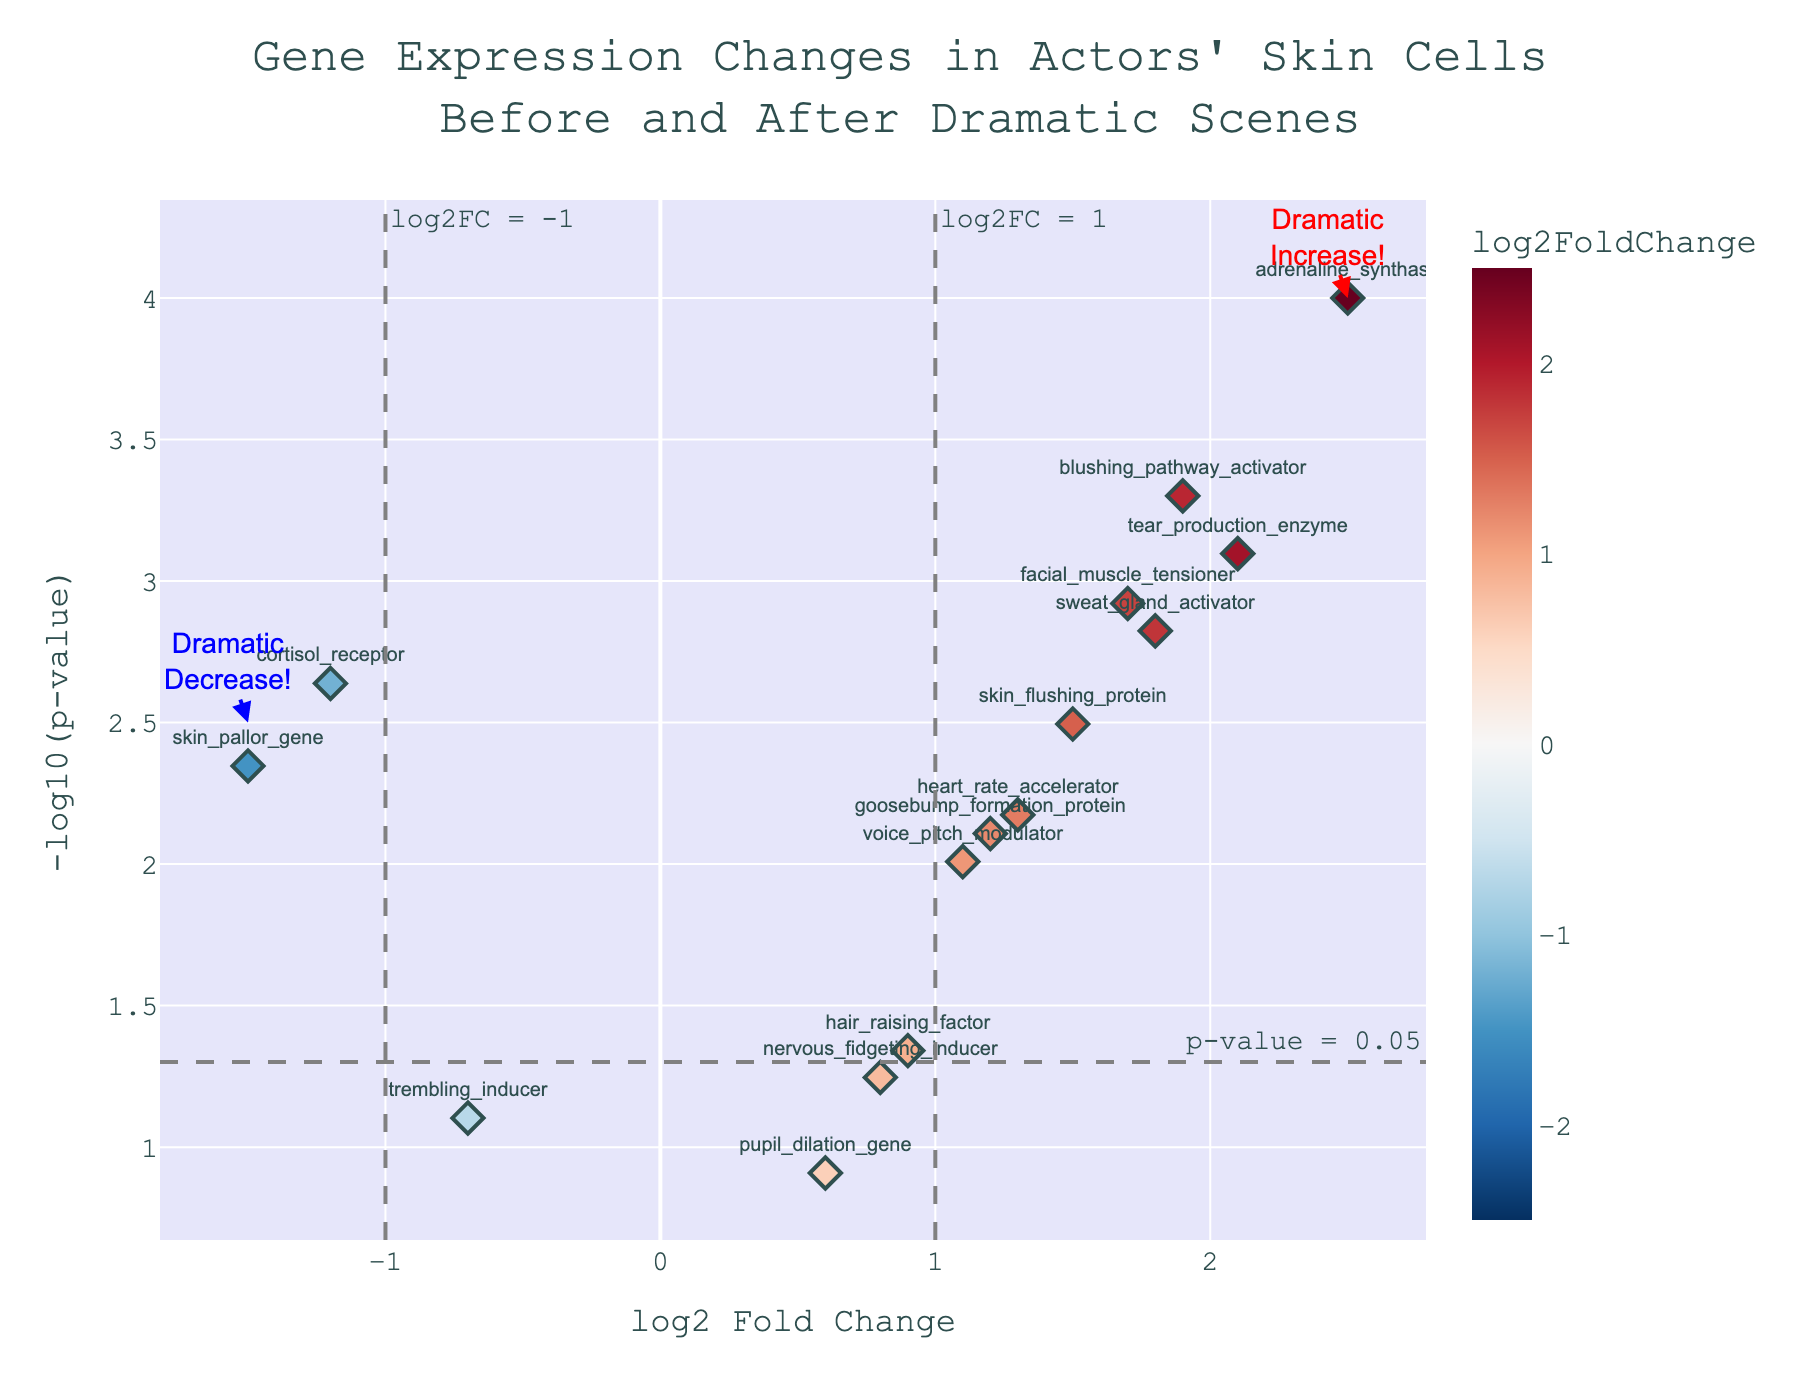What's the title of the plot? The title of the plot is usually located at the top-center of the figure. Reading this text should give us the title.
Answer: "Gene Expression Changes in Actors' Skin Cells Before and After Dramatic Scenes" How many genes have a p-value less than 0.05? In a volcano plot, the genes with p-values less than 0.05 are found above the horizontal threshold line labeled "p-value = 0.05." Count the number of points above this line.
Answer: 12 Which gene shows the most dramatic increase in expression? In a volcano plot, the most dramatic increase in expression corresponds to the gene with the highest positive log2 Fold Change and a significant p-value. This gene is often annotated or located farthest to the right on the plot.
Answer: adrenaline_synthase Which gene shows the highest log2 Fold Change? Look to the rightmost point on the x-axis (log2 Fold Change). This point represents the gene with the highest log2 Fold Change value.
Answer: adrenaline_synthase What's the log2 Fold Change for the 'skin_flushing_protein' gene? Find the point labeled 'skin_flushing_protein' and read its value on the x-axis for the log2 Fold Change.
Answer: 1.5 How many genes exhibit a significant increase in expression? Significant increases are shown by points with a log2 Fold Change > 1 and a p-value < 0.05. Count these points to get the answer.
Answer: 7 Which genes have a log2 Fold Change between 1 and 2? Identify all points that fall within this range on the x-axis and check their labels to find the corresponding genes.
Answer: sweat_gland_activator, heart_rate_accelerator, goosebump_formation_protein, voice_pitch_modulator, skin_flushing_protein, blushing_pathway_activator, facial_muscle_tensioner What is the p-value threshold used as a reference line in this plot? The reference line for p-value threshold is usually annotated on the plot. Locate this horizontal line and read the annotation.
Answer: 0.05 Out of the genes with significant expression changes, which shows a decrease? Significant decreases are shown by points with a log2 Fold Change < -1 and a p-value < 0.05. Look for these annotations on the left side of the plot.
Answer: cortisol_receptor, skin_pallor_gene 